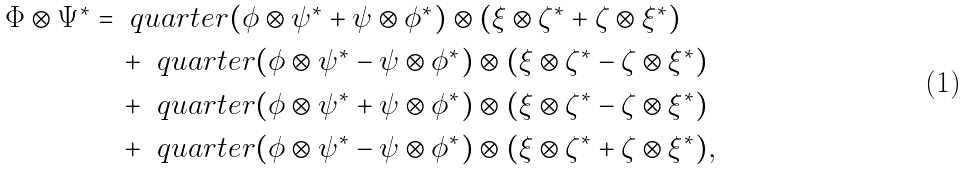Convert formula to latex. <formula><loc_0><loc_0><loc_500><loc_500>\Phi \otimes \Psi ^ { * } & = \ q u a r t e r ( \phi \otimes \psi ^ { * } + \psi \otimes \phi ^ { * } ) \otimes ( \xi \otimes \zeta ^ { * } + \zeta \otimes \xi ^ { * } ) \\ & \quad + \ q u a r t e r ( \phi \otimes \psi ^ { * } - \psi \otimes \phi ^ { * } ) \otimes ( \xi \otimes \zeta ^ { * } - \zeta \otimes \xi ^ { * } ) \\ & \quad + \ q u a r t e r ( \phi \otimes \psi ^ { * } + \psi \otimes \phi ^ { * } ) \otimes ( \xi \otimes \zeta ^ { * } - \zeta \otimes \xi ^ { * } ) \\ & \quad + \ q u a r t e r ( \phi \otimes \psi ^ { * } - \psi \otimes \phi ^ { * } ) \otimes ( \xi \otimes \zeta ^ { * } + \zeta \otimes \xi ^ { * } ) ,</formula> 